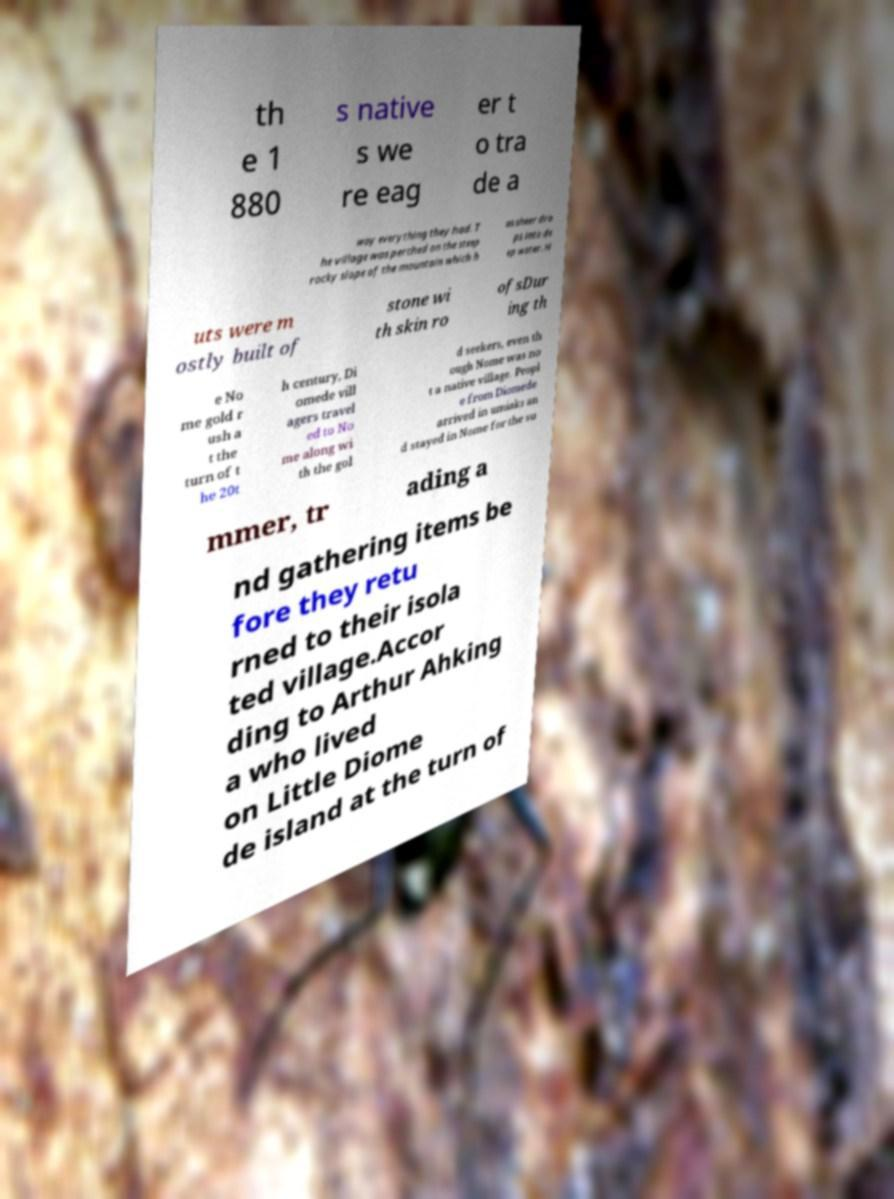Can you accurately transcribe the text from the provided image for me? th e 1 880 s native s we re eag er t o tra de a way everything they had. T he village was perched on the steep rocky slope of the mountain which h as sheer dro ps into de ep water. H uts were m ostly built of stone wi th skin ro ofsDur ing th e No me gold r ush a t the turn of t he 20t h century, Di omede vill agers travel ed to No me along wi th the gol d seekers, even th ough Nome was no t a native village. Peopl e from Diomede arrived in umiaks an d stayed in Nome for the su mmer, tr ading a nd gathering items be fore they retu rned to their isola ted village.Accor ding to Arthur Ahking a who lived on Little Diome de island at the turn of 